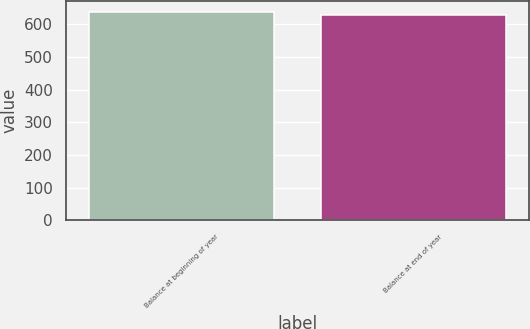<chart> <loc_0><loc_0><loc_500><loc_500><bar_chart><fcel>Balance at beginning of year<fcel>Balance at end of year<nl><fcel>638<fcel>628<nl></chart> 